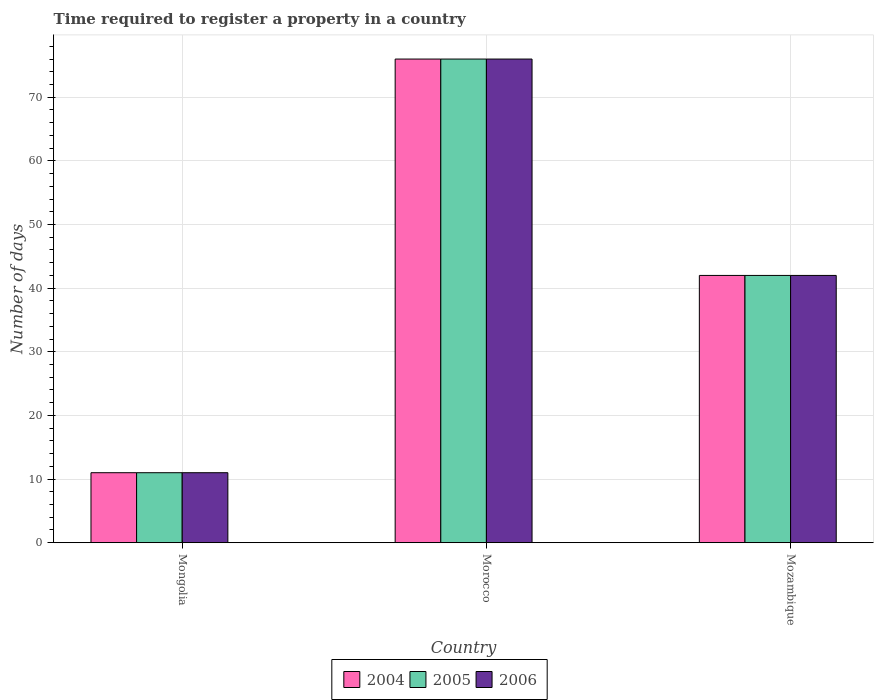How many different coloured bars are there?
Give a very brief answer. 3. How many groups of bars are there?
Keep it short and to the point. 3. Are the number of bars per tick equal to the number of legend labels?
Provide a short and direct response. Yes. How many bars are there on the 1st tick from the right?
Offer a terse response. 3. What is the label of the 2nd group of bars from the left?
Offer a very short reply. Morocco. In how many cases, is the number of bars for a given country not equal to the number of legend labels?
Your response must be concise. 0. What is the number of days required to register a property in 2006 in Mongolia?
Keep it short and to the point. 11. Across all countries, what is the maximum number of days required to register a property in 2005?
Offer a terse response. 76. Across all countries, what is the minimum number of days required to register a property in 2004?
Your response must be concise. 11. In which country was the number of days required to register a property in 2005 maximum?
Ensure brevity in your answer.  Morocco. In which country was the number of days required to register a property in 2005 minimum?
Ensure brevity in your answer.  Mongolia. What is the total number of days required to register a property in 2004 in the graph?
Offer a terse response. 129. In how many countries, is the number of days required to register a property in 2005 greater than 54 days?
Offer a terse response. 1. What is the ratio of the number of days required to register a property in 2005 in Mongolia to that in Morocco?
Provide a short and direct response. 0.14. Is the difference between the number of days required to register a property in 2005 in Mongolia and Morocco greater than the difference between the number of days required to register a property in 2006 in Mongolia and Morocco?
Make the answer very short. No. What is the difference between the highest and the second highest number of days required to register a property in 2004?
Keep it short and to the point. 31. In how many countries, is the number of days required to register a property in 2006 greater than the average number of days required to register a property in 2006 taken over all countries?
Your response must be concise. 1. Is the sum of the number of days required to register a property in 2005 in Mongolia and Mozambique greater than the maximum number of days required to register a property in 2004 across all countries?
Offer a very short reply. No. What does the 1st bar from the left in Mozambique represents?
Offer a terse response. 2004. How many bars are there?
Your response must be concise. 9. How many countries are there in the graph?
Your response must be concise. 3. Does the graph contain grids?
Keep it short and to the point. Yes. What is the title of the graph?
Give a very brief answer. Time required to register a property in a country. Does "1975" appear as one of the legend labels in the graph?
Give a very brief answer. No. What is the label or title of the Y-axis?
Offer a terse response. Number of days. What is the Number of days in 2004 in Mongolia?
Your response must be concise. 11. What is the Number of days of 2005 in Mongolia?
Provide a short and direct response. 11. What is the Number of days of 2006 in Mongolia?
Your response must be concise. 11. What is the Number of days in 2004 in Morocco?
Your answer should be very brief. 76. What is the Number of days of 2004 in Mozambique?
Offer a very short reply. 42. Across all countries, what is the maximum Number of days in 2004?
Keep it short and to the point. 76. Across all countries, what is the minimum Number of days of 2004?
Your answer should be very brief. 11. Across all countries, what is the minimum Number of days of 2006?
Provide a short and direct response. 11. What is the total Number of days of 2004 in the graph?
Offer a very short reply. 129. What is the total Number of days of 2005 in the graph?
Make the answer very short. 129. What is the total Number of days in 2006 in the graph?
Make the answer very short. 129. What is the difference between the Number of days in 2004 in Mongolia and that in Morocco?
Your answer should be compact. -65. What is the difference between the Number of days of 2005 in Mongolia and that in Morocco?
Provide a succinct answer. -65. What is the difference between the Number of days of 2006 in Mongolia and that in Morocco?
Keep it short and to the point. -65. What is the difference between the Number of days in 2004 in Mongolia and that in Mozambique?
Your answer should be compact. -31. What is the difference between the Number of days of 2005 in Mongolia and that in Mozambique?
Make the answer very short. -31. What is the difference between the Number of days of 2006 in Mongolia and that in Mozambique?
Provide a succinct answer. -31. What is the difference between the Number of days of 2004 in Morocco and that in Mozambique?
Your answer should be very brief. 34. What is the difference between the Number of days of 2006 in Morocco and that in Mozambique?
Provide a short and direct response. 34. What is the difference between the Number of days of 2004 in Mongolia and the Number of days of 2005 in Morocco?
Provide a succinct answer. -65. What is the difference between the Number of days of 2004 in Mongolia and the Number of days of 2006 in Morocco?
Your response must be concise. -65. What is the difference between the Number of days of 2005 in Mongolia and the Number of days of 2006 in Morocco?
Your response must be concise. -65. What is the difference between the Number of days of 2004 in Mongolia and the Number of days of 2005 in Mozambique?
Ensure brevity in your answer.  -31. What is the difference between the Number of days of 2004 in Mongolia and the Number of days of 2006 in Mozambique?
Offer a terse response. -31. What is the difference between the Number of days of 2005 in Mongolia and the Number of days of 2006 in Mozambique?
Make the answer very short. -31. What is the difference between the Number of days of 2004 in Morocco and the Number of days of 2005 in Mozambique?
Your answer should be very brief. 34. What is the difference between the Number of days in 2004 in Morocco and the Number of days in 2006 in Mozambique?
Give a very brief answer. 34. What is the average Number of days in 2004 per country?
Your response must be concise. 43. What is the average Number of days in 2006 per country?
Offer a very short reply. 43. What is the difference between the Number of days of 2005 and Number of days of 2006 in Mongolia?
Provide a succinct answer. 0. What is the difference between the Number of days in 2005 and Number of days in 2006 in Morocco?
Make the answer very short. 0. What is the ratio of the Number of days of 2004 in Mongolia to that in Morocco?
Provide a short and direct response. 0.14. What is the ratio of the Number of days of 2005 in Mongolia to that in Morocco?
Your response must be concise. 0.14. What is the ratio of the Number of days in 2006 in Mongolia to that in Morocco?
Your answer should be compact. 0.14. What is the ratio of the Number of days in 2004 in Mongolia to that in Mozambique?
Offer a terse response. 0.26. What is the ratio of the Number of days in 2005 in Mongolia to that in Mozambique?
Your answer should be very brief. 0.26. What is the ratio of the Number of days of 2006 in Mongolia to that in Mozambique?
Keep it short and to the point. 0.26. What is the ratio of the Number of days of 2004 in Morocco to that in Mozambique?
Make the answer very short. 1.81. What is the ratio of the Number of days in 2005 in Morocco to that in Mozambique?
Keep it short and to the point. 1.81. What is the ratio of the Number of days of 2006 in Morocco to that in Mozambique?
Your response must be concise. 1.81. What is the difference between the highest and the second highest Number of days in 2004?
Give a very brief answer. 34. What is the difference between the highest and the second highest Number of days in 2005?
Keep it short and to the point. 34. What is the difference between the highest and the second highest Number of days in 2006?
Keep it short and to the point. 34. What is the difference between the highest and the lowest Number of days of 2004?
Your answer should be very brief. 65. What is the difference between the highest and the lowest Number of days in 2005?
Ensure brevity in your answer.  65. What is the difference between the highest and the lowest Number of days in 2006?
Your response must be concise. 65. 